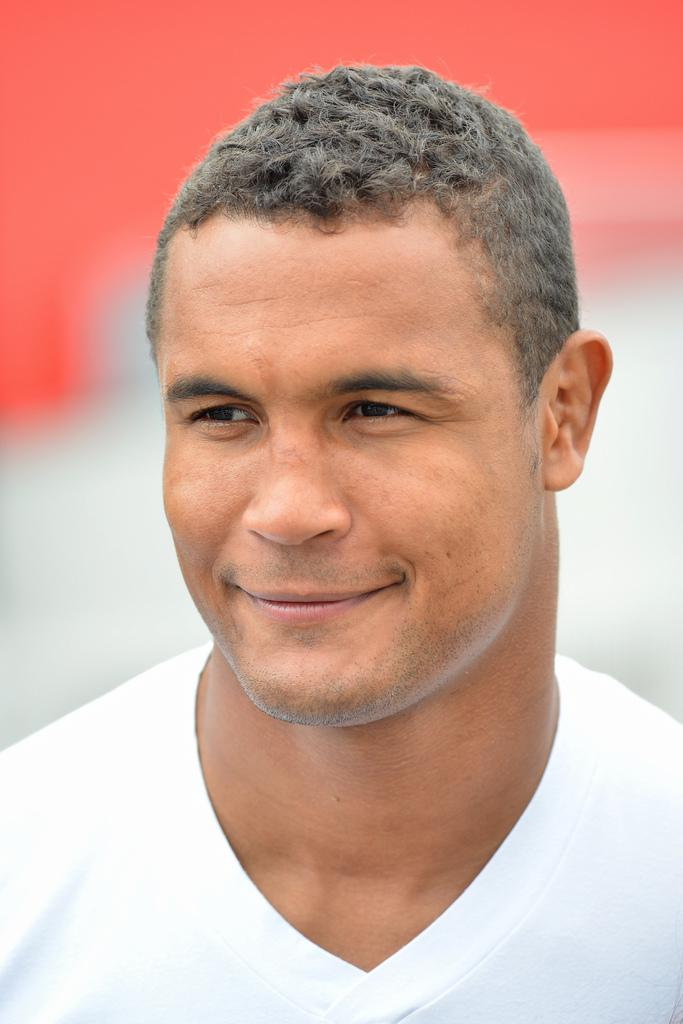What is the main subject of the image? There is a man in the middle of the image. What is the man's facial expression? The man has a smiling face. How would you describe the background of the image? The background of the image is blurred. What colors are present in the background? The background colors are red and white. How many snails can be seen crawling on the man's face in the image? There are no snails present in the image; the man's face is smiling and not covered by any creatures. 